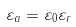Convert formula to latex. <formula><loc_0><loc_0><loc_500><loc_500>\varepsilon _ { a } = \varepsilon _ { 0 } \varepsilon _ { r }</formula> 